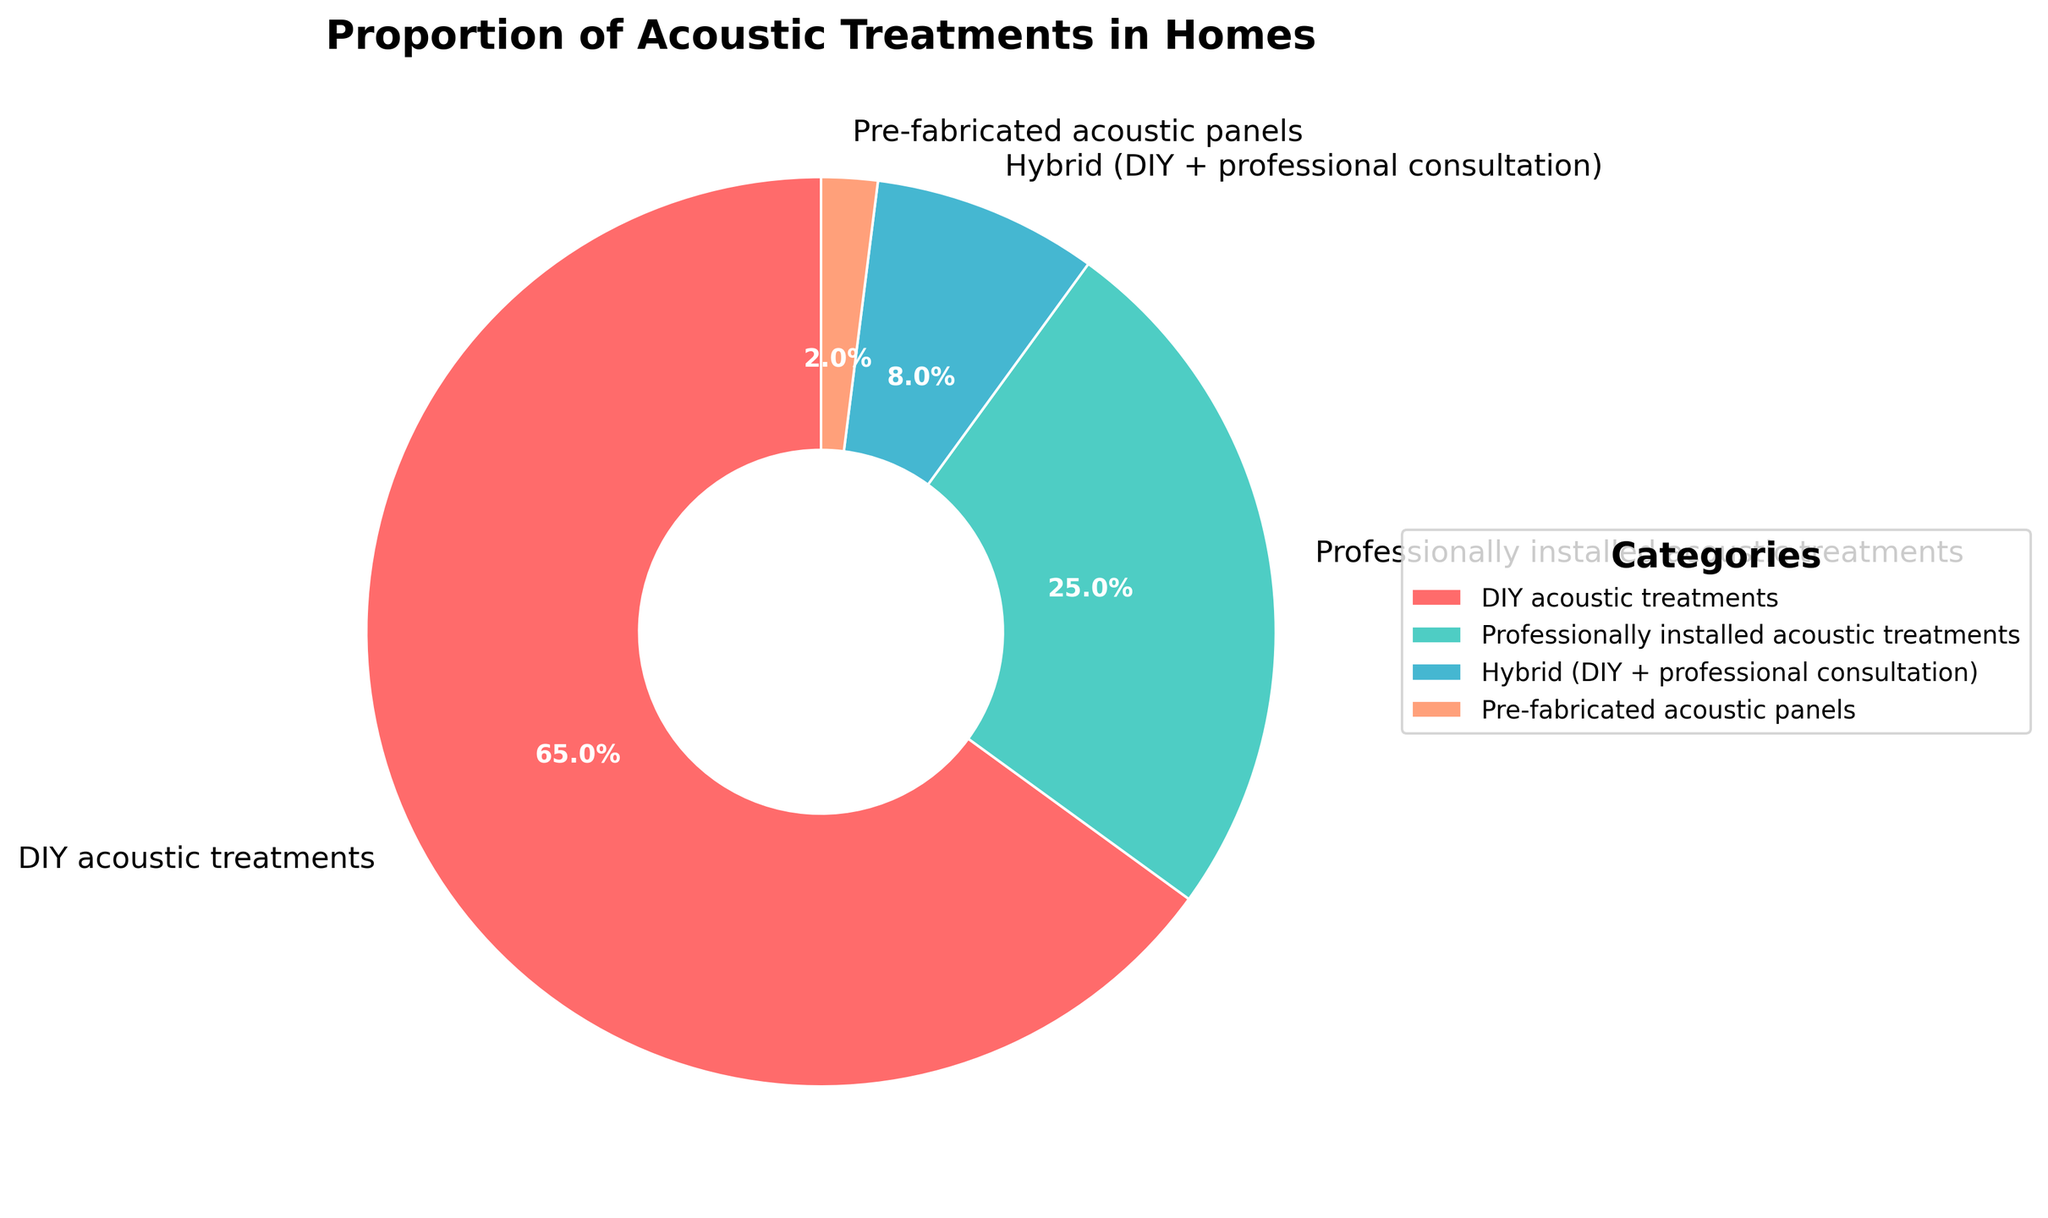What category has the highest proportion of acoustic treatments? The pie chart shows four categories with their percentages. DIY acoustic treatments have the highest percentage.
Answer: DIY acoustic treatments What is the combined percentage of professionally installed and pre-fabricated acoustic treatments? Adding the percentages of professionally installed acoustic treatments (25%) and pre-fabricated acoustic panels (2%) gives a combined percentage. 25% + 2% = 27%
Answer: 27% How much more common are DIY acoustic treatments compared to hybrid treatments? The pie chart shows DIY acoustic treatments at 65% and hybrid treatments at 8%. Subtracting the smaller percentage from the larger gives the difference. 65% - 8% = 57%
Answer: 57% Which category has the smallest proportion? The pie chart displays four categories with attached percentages. The pre-fabricated acoustic panels have the smallest with 2%.
Answer: Pre-fabricated acoustic panels Rank the categories from highest to lowest proportion. The pie chart displays percentages for four categories. Ranking them from highest to lowest gives: DIY acoustic treatments (65%), professionally installed acoustic treatments (25%), hybrid (8%), and pre-fabricated acoustic panels (2%).
Answer: DIY acoustic treatments > Professionally installed acoustic treatments > Hybrid > Pre-fabricated acoustic panels What percentage of the treatments are not DIY? Subtracting the percentage of DIY acoustic treatments from the total (100%) gives the proportion of non-DIY. 100% - 65% = 35%
Answer: 35% How does the proportion of hybrid treatments compare to the proportion of professionally installed treatments? The pie chart shows hybrid treatments at 8% and professionally installed treatments at 25%. 25% is more than 8%.
Answer: Professionally installed treatments are more common What is the difference in proportion between the largest and the smallest categories? The largest category (DIY acoustic treatments) has 65%, and the smallest category (pre-fabricated acoustic panels) has 2%. The difference is calculated by subtracting the smaller percentage from the larger one. 65% - 2% = 63%
Answer: 63% What portion of the total is represented by hybrid and pre-fabricated treatments combined? Adding percentages for hybrid (8%) and pre-fabricated acoustic panels (2%) results in the combined proportion. 8% + 2% = 10%
Answer: 10% What's the visual representation of the professionally installed treatments' percentage in the pie chart? The portion of the pie chart colored blue represents 25%, indicating the professionally installed treatments.
Answer: 25% (blue) 